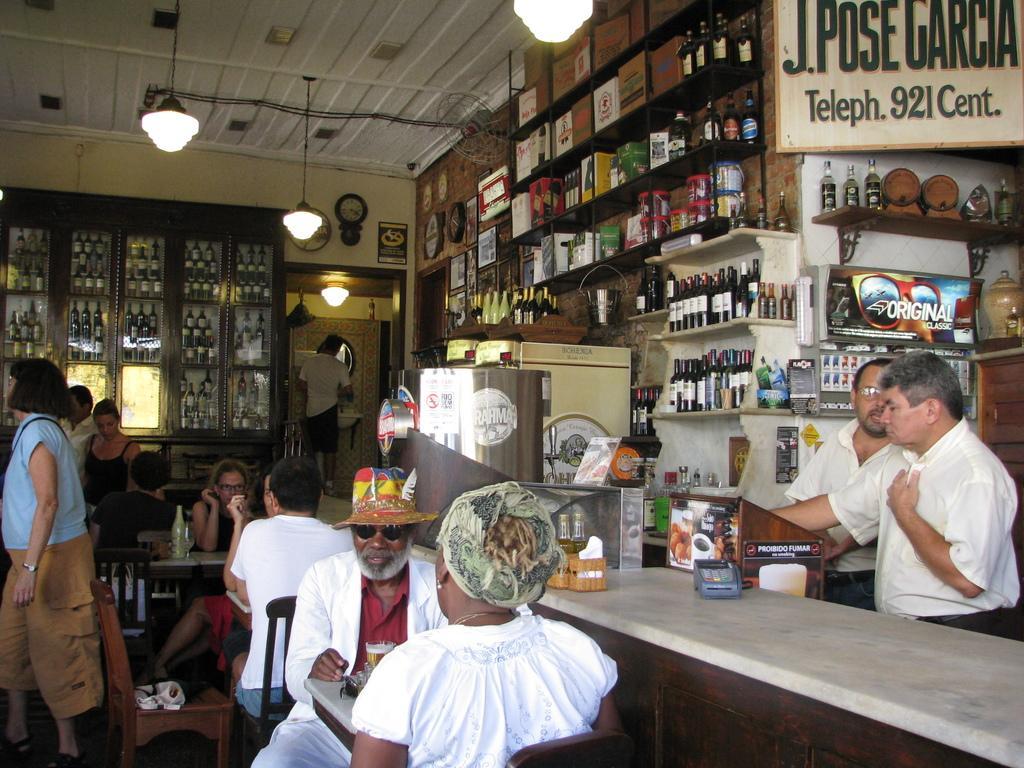Could you give a brief overview of what you see in this image? In this image there are group of people some of them are sitting and some of them are standing and some of them are walking and on the top there is ceiling and lights as it seems that this is a store. On the right side there are some bottles and some packets are there. And in the middle of the image there is one clock and wall and on the left side of the image there is one glass cupboard and in that cupboard there are some bottles and in the foreground there are some tables and chairs are there. 